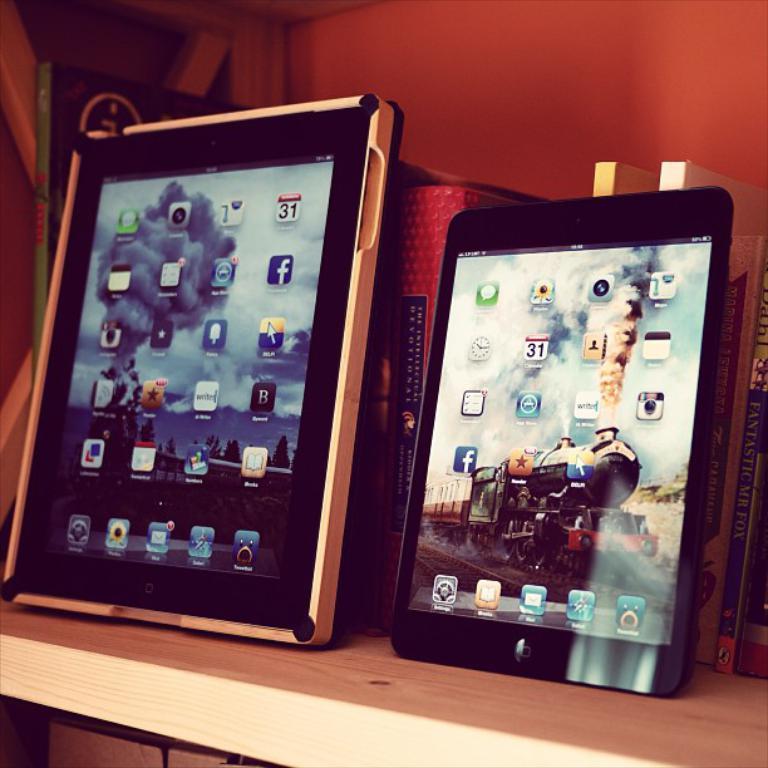Please provide a concise description of this image. In this image, we can see the iPad's, few books are placed on the wooden rack. Background we can see a wall. In the iPad screens, we can see icons and images. 